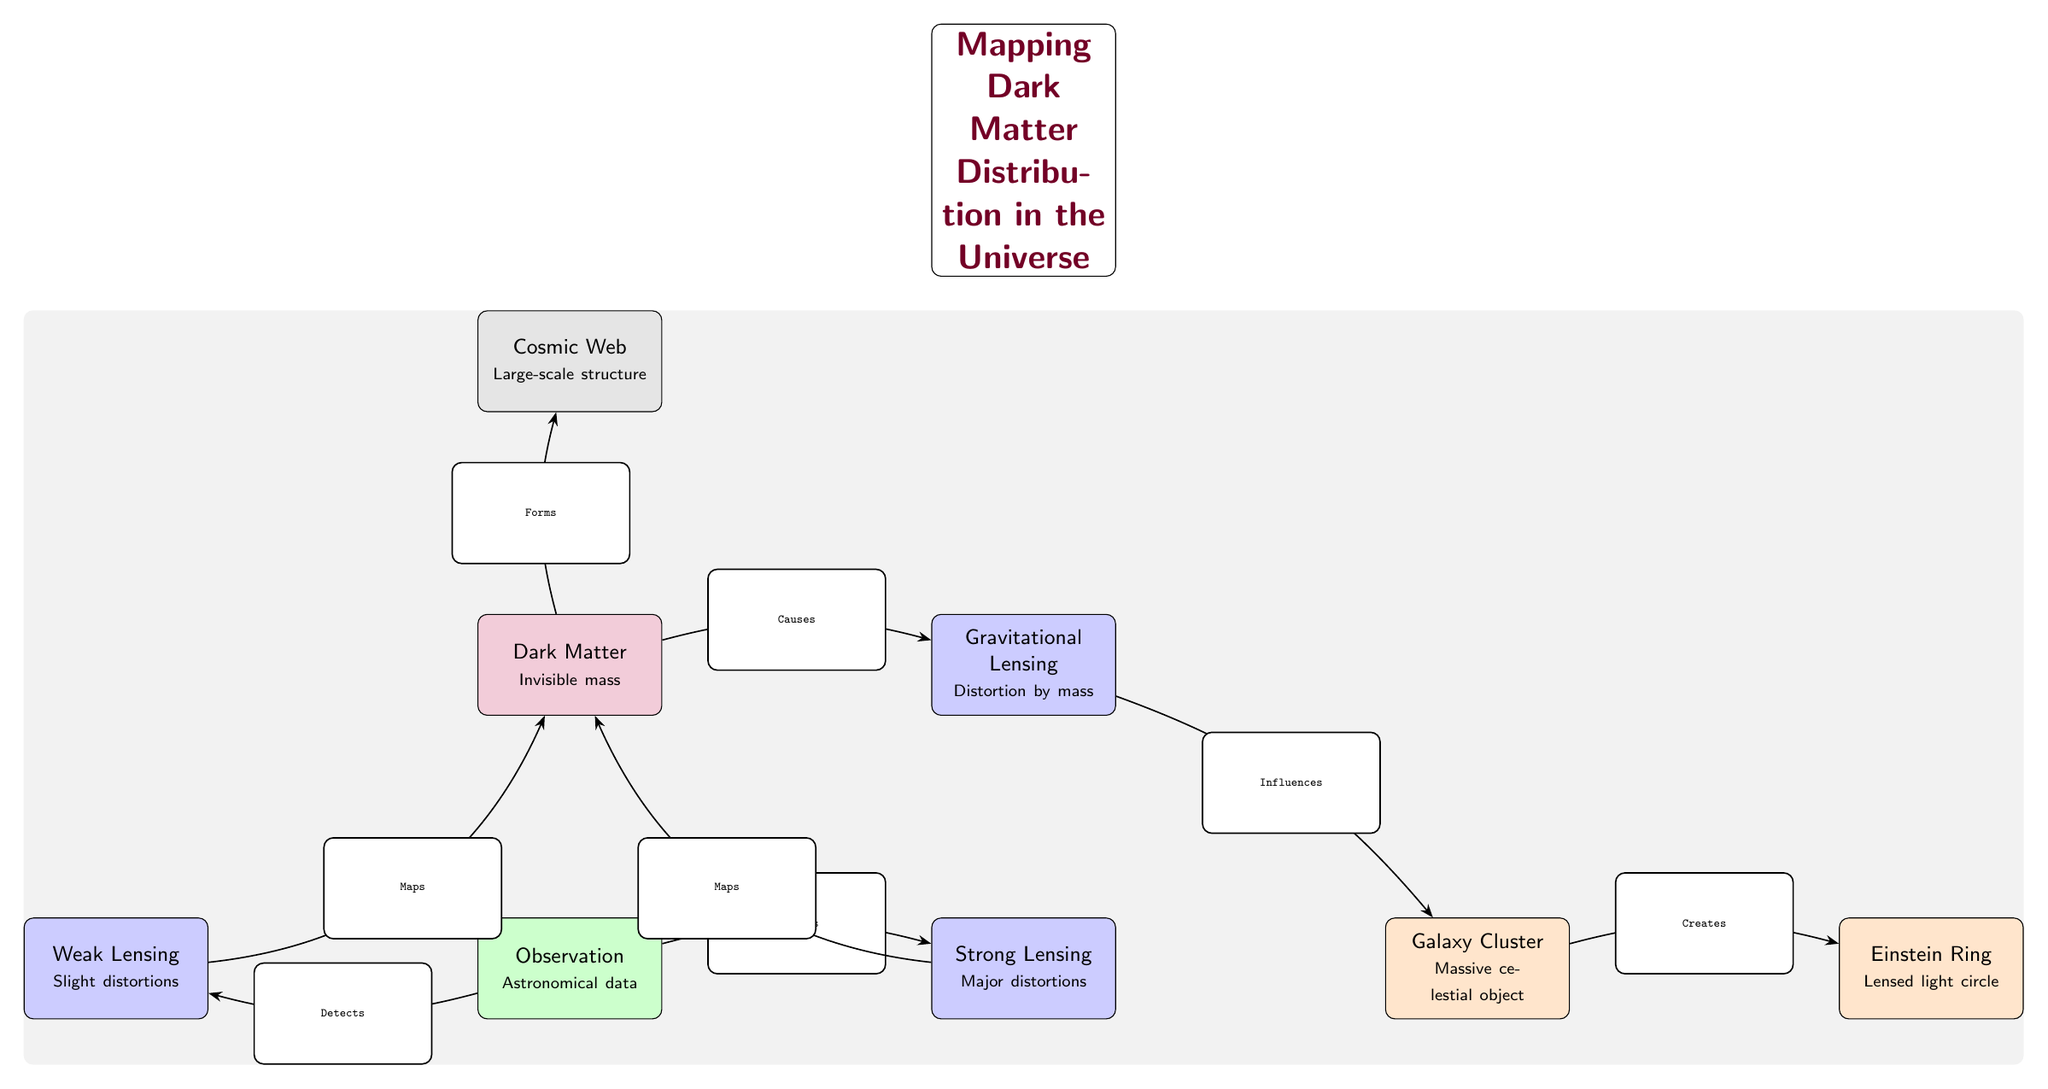What is the type of matter depicted in the diagram? The diagram identifies the type of matter as "Dark Matter," which is labeled in a node at the top left.
Answer: Dark Matter How many types of lensing are indicated in the diagram? The diagram shows two types of lensing: "Weak Lensing" and "Strong Lensing," both represented by separate nodes.
Answer: Two What does the "Gravitational Lensing" node influence? The arrow from the "Gravitational Lensing" node points to the "Galaxy Cluster" node, indicating that it influences this component.
Answer: Galaxy Cluster What does the "Galaxy Cluster" create? The diagram depicts an arrow leading from the "Galaxy Cluster" node to the "Einstein Ring" node, indicating it creates this structure.
Answer: Einstein Ring Which component detects data? The "Observation" node, which is centrally located in the diagram, has arrows leading to both the "Weak Lensing" and "Strong Lensing" nodes, showing it detects these aspects.
Answer: Observation How does weak lensing relate to dark matter? The weak lensing node has a directed edge labeled "Maps" leading back to the "Dark Matter" node, indicating it is used to map dark matter distribution.
Answer: Maps Which node shows the large-scale structure of the universe? The "Cosmic Web" node at the top of the diagram signifies the large-scale structure of the universe.
Answer: Cosmic Web What role does dark matter play concerning the cosmic web? The diagram indicates that dark matter "Forms" the cosmic web, as shown by the directed edge from "Dark Matter" to "Cosmic Web."
Answer: Forms What types of observations can be detected according to the diagram? The diagram specifies two types: "Weak Lensing" and "Strong Lensing," both connected to the "Observation" node.
Answer: Weak Lensing, Strong Lensing 